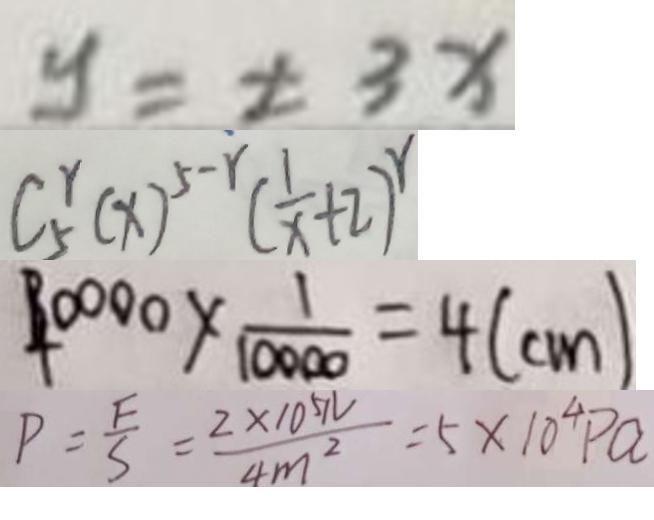<formula> <loc_0><loc_0><loc_500><loc_500>y = \pm 3 x 
 C _ { 5 } ^ { r } ( x ) ^ { 5 - r } ( \frac { 1 } { x } + 2 ) ^ { r } 
 4 0 0 0 0 \times \frac { 1 } { 1 0 0 0 0 } = 4 ( c m ) 
 P = \frac { F } { S } = \frac { 2 \times 1 0 ^ { 5 } N } { 4 m ^ { 2 } } = 5 \times 1 0 ^ { 4 } P a</formula> 